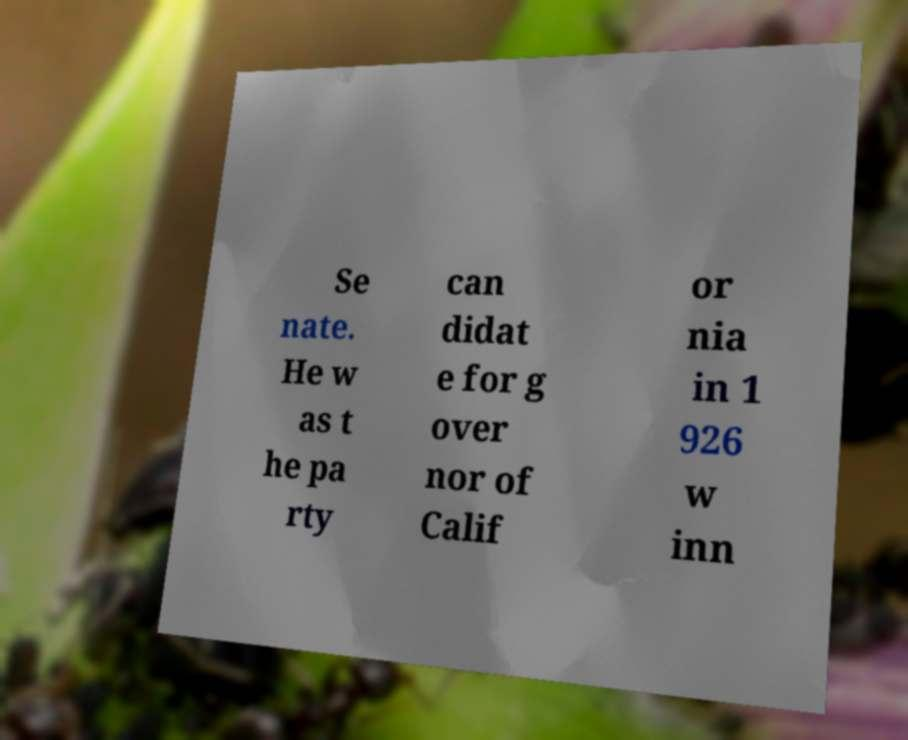Please read and relay the text visible in this image. What does it say? Se nate. He w as t he pa rty can didat e for g over nor of Calif or nia in 1 926 w inn 